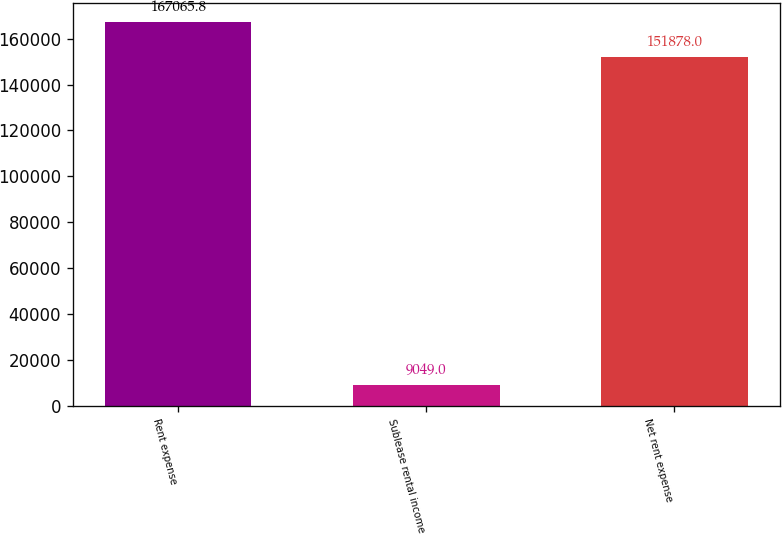<chart> <loc_0><loc_0><loc_500><loc_500><bar_chart><fcel>Rent expense<fcel>Sublease rental income<fcel>Net rent expense<nl><fcel>167066<fcel>9049<fcel>151878<nl></chart> 